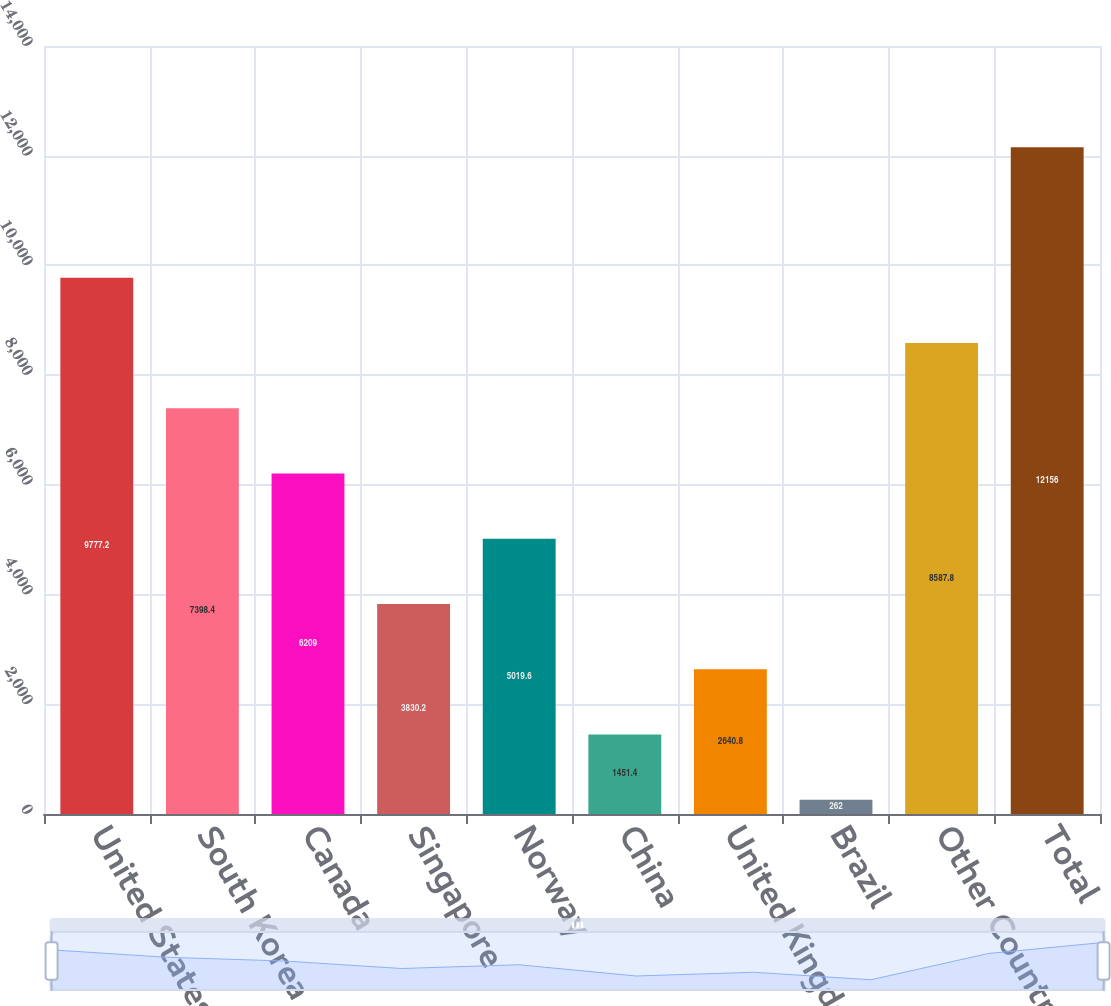Convert chart. <chart><loc_0><loc_0><loc_500><loc_500><bar_chart><fcel>United States<fcel>South Korea<fcel>Canada<fcel>Singapore<fcel>Norway<fcel>China<fcel>United Kingdom<fcel>Brazil<fcel>Other Countries<fcel>Total<nl><fcel>9777.2<fcel>7398.4<fcel>6209<fcel>3830.2<fcel>5019.6<fcel>1451.4<fcel>2640.8<fcel>262<fcel>8587.8<fcel>12156<nl></chart> 